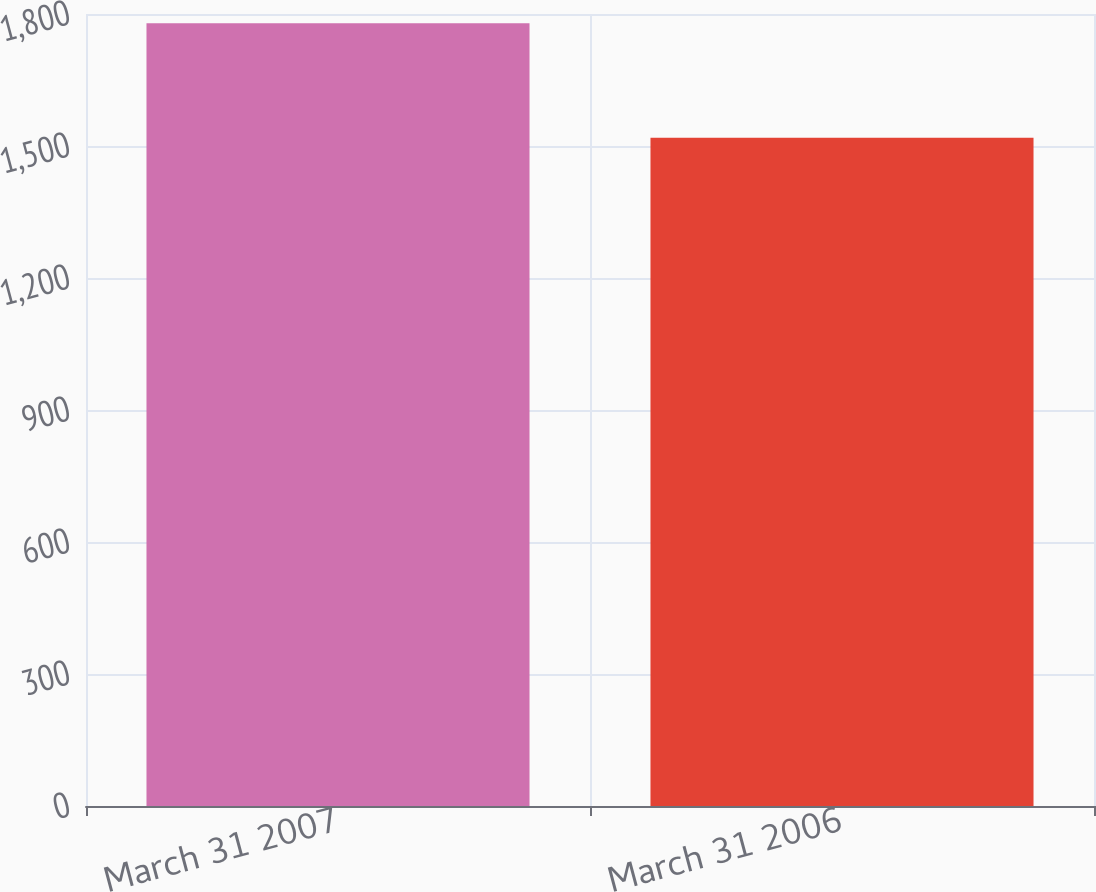Convert chart. <chart><loc_0><loc_0><loc_500><loc_500><bar_chart><fcel>March 31 2007<fcel>March 31 2006<nl><fcel>1779<fcel>1519<nl></chart> 